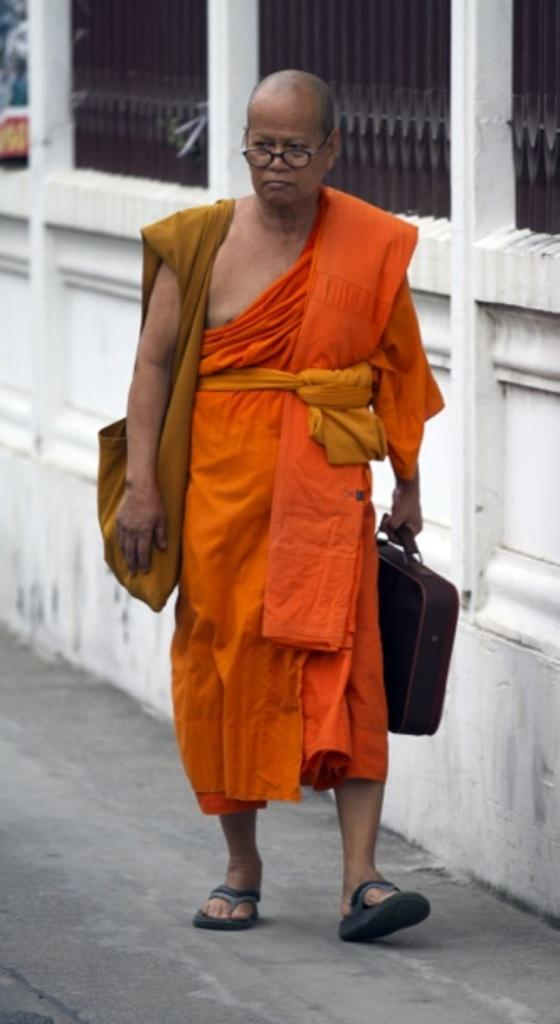What is the main subject of the image? There is a man in the image. What is the man doing in the image? The man is walking on a path. What is the man holding in the image? The man is holding a bag. What is the man carrying in the image? The man is carrying a bag. What color are the clothes the man is wearing? The man is wearing orange clothes. What can be seen in the background of the image? There is a boundary in the background of the image. What type of lipstick is the man applying in the image? There is no lipstick or any indication of the man applying lipstick in the image. What type of tools does the carpenter have in the image? There is no carpenter or any tools present in the image. 